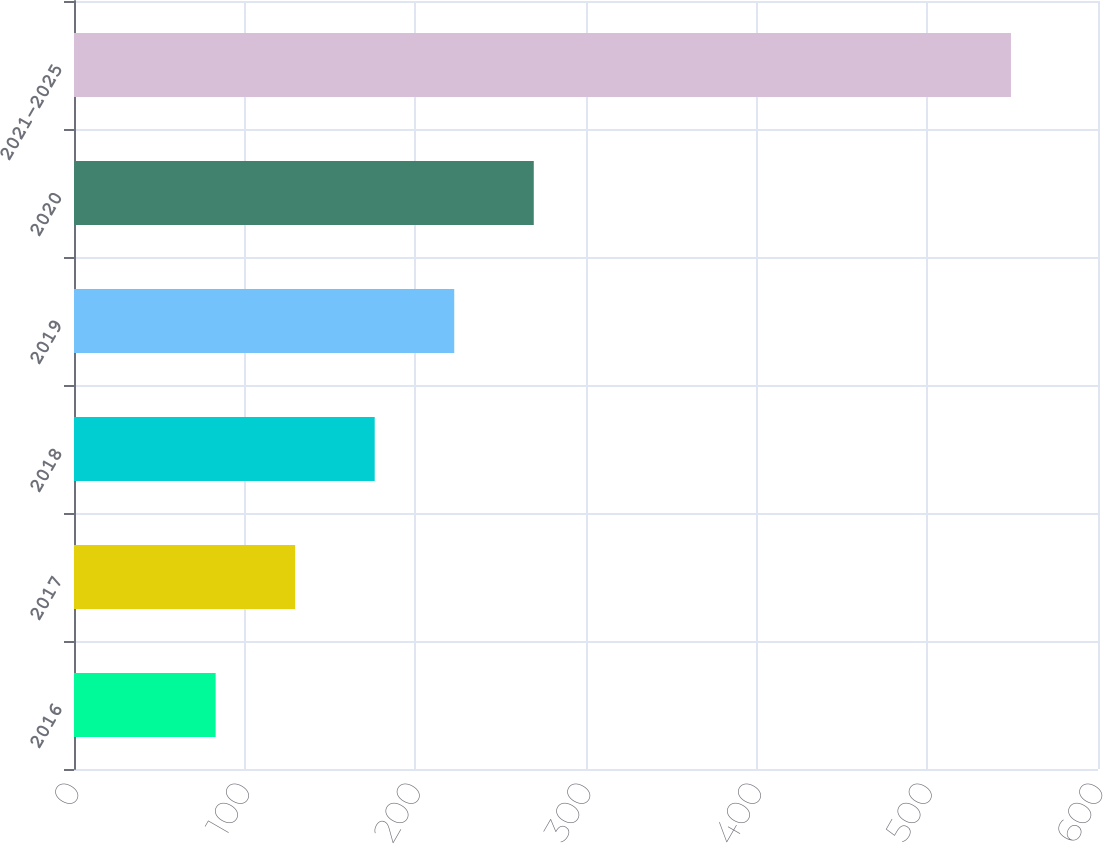<chart> <loc_0><loc_0><loc_500><loc_500><bar_chart><fcel>2016<fcel>2017<fcel>2018<fcel>2019<fcel>2020<fcel>2021-2025<nl><fcel>83<fcel>129.6<fcel>176.2<fcel>222.8<fcel>269.4<fcel>549<nl></chart> 